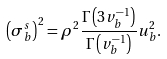<formula> <loc_0><loc_0><loc_500><loc_500>\left ( \sigma _ { b } ^ { s } \right ) ^ { 2 } = \rho ^ { 2 } \frac { \Gamma \left ( 3 v _ { b } ^ { - 1 } \right ) } { \Gamma \left ( v _ { b } ^ { - 1 } \right ) } u _ { b } ^ { 2 } .</formula> 